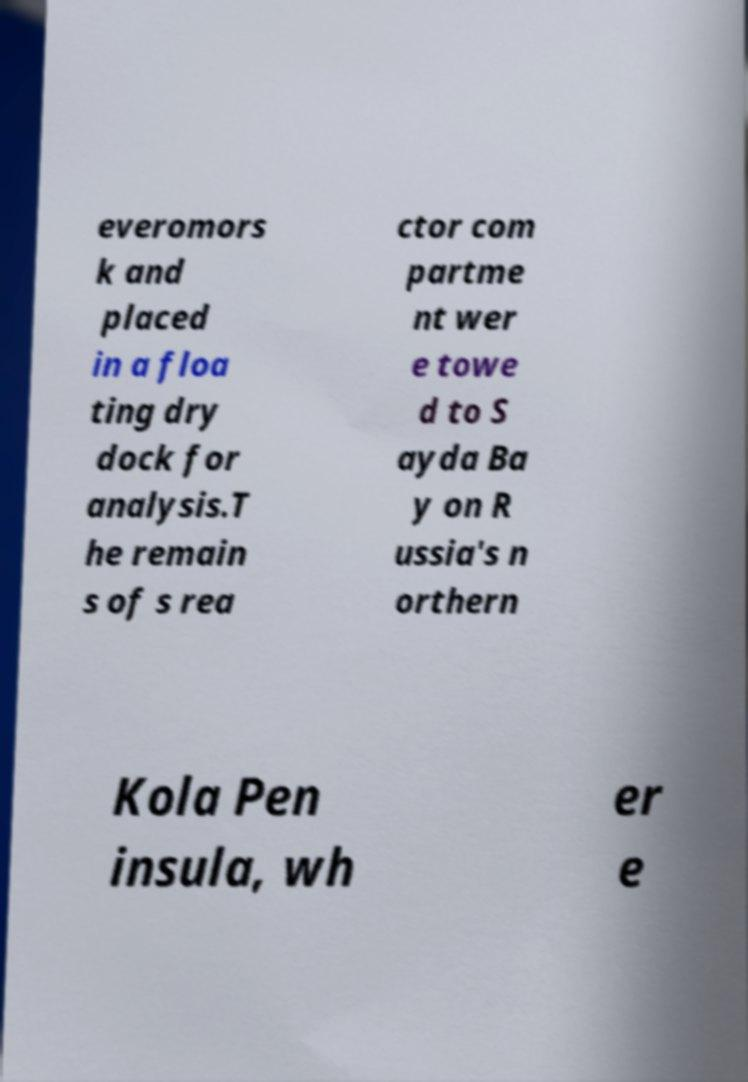Please identify and transcribe the text found in this image. everomors k and placed in a floa ting dry dock for analysis.T he remain s of s rea ctor com partme nt wer e towe d to S ayda Ba y on R ussia's n orthern Kola Pen insula, wh er e 